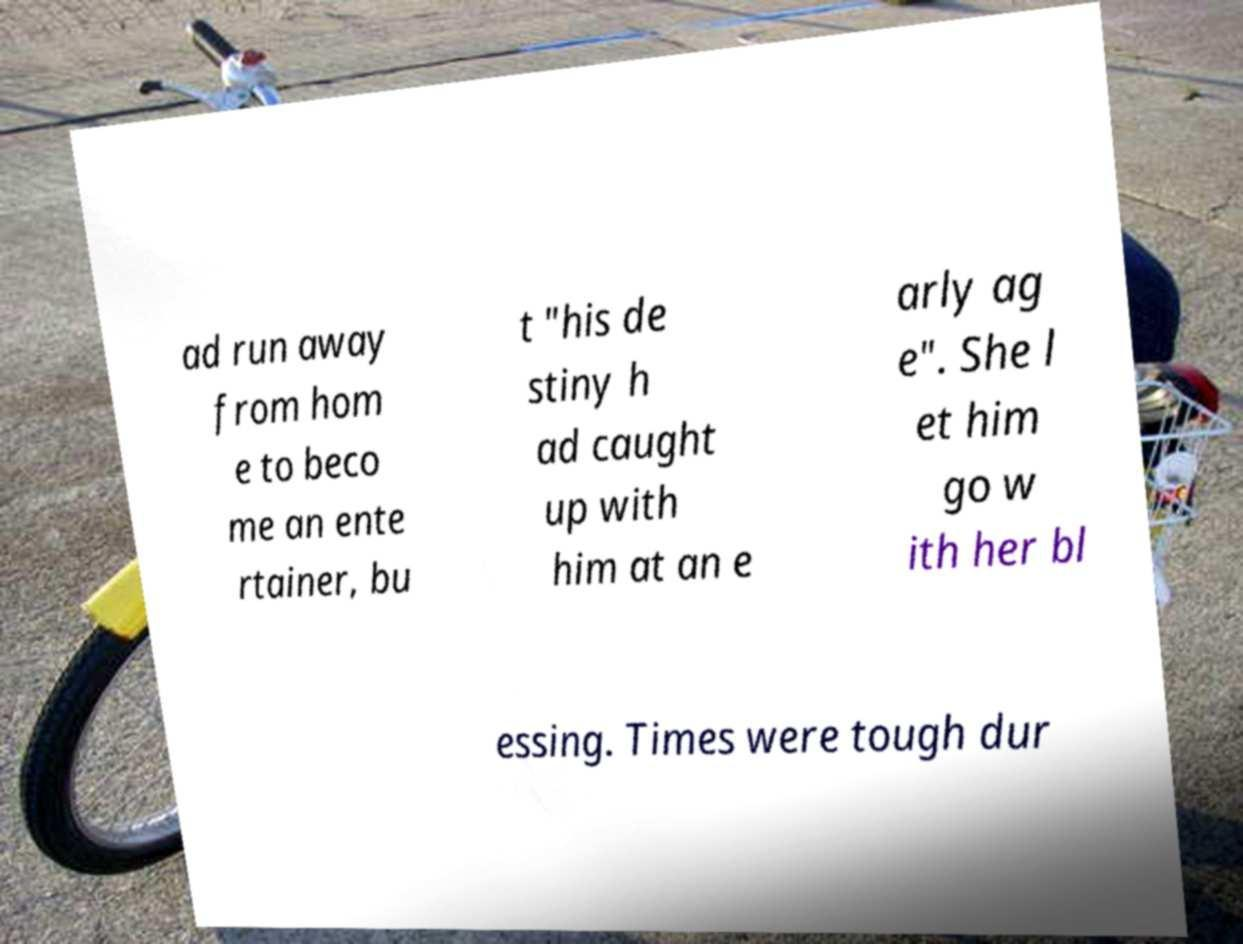I need the written content from this picture converted into text. Can you do that? ad run away from hom e to beco me an ente rtainer, bu t "his de stiny h ad caught up with him at an e arly ag e". She l et him go w ith her bl essing. Times were tough dur 